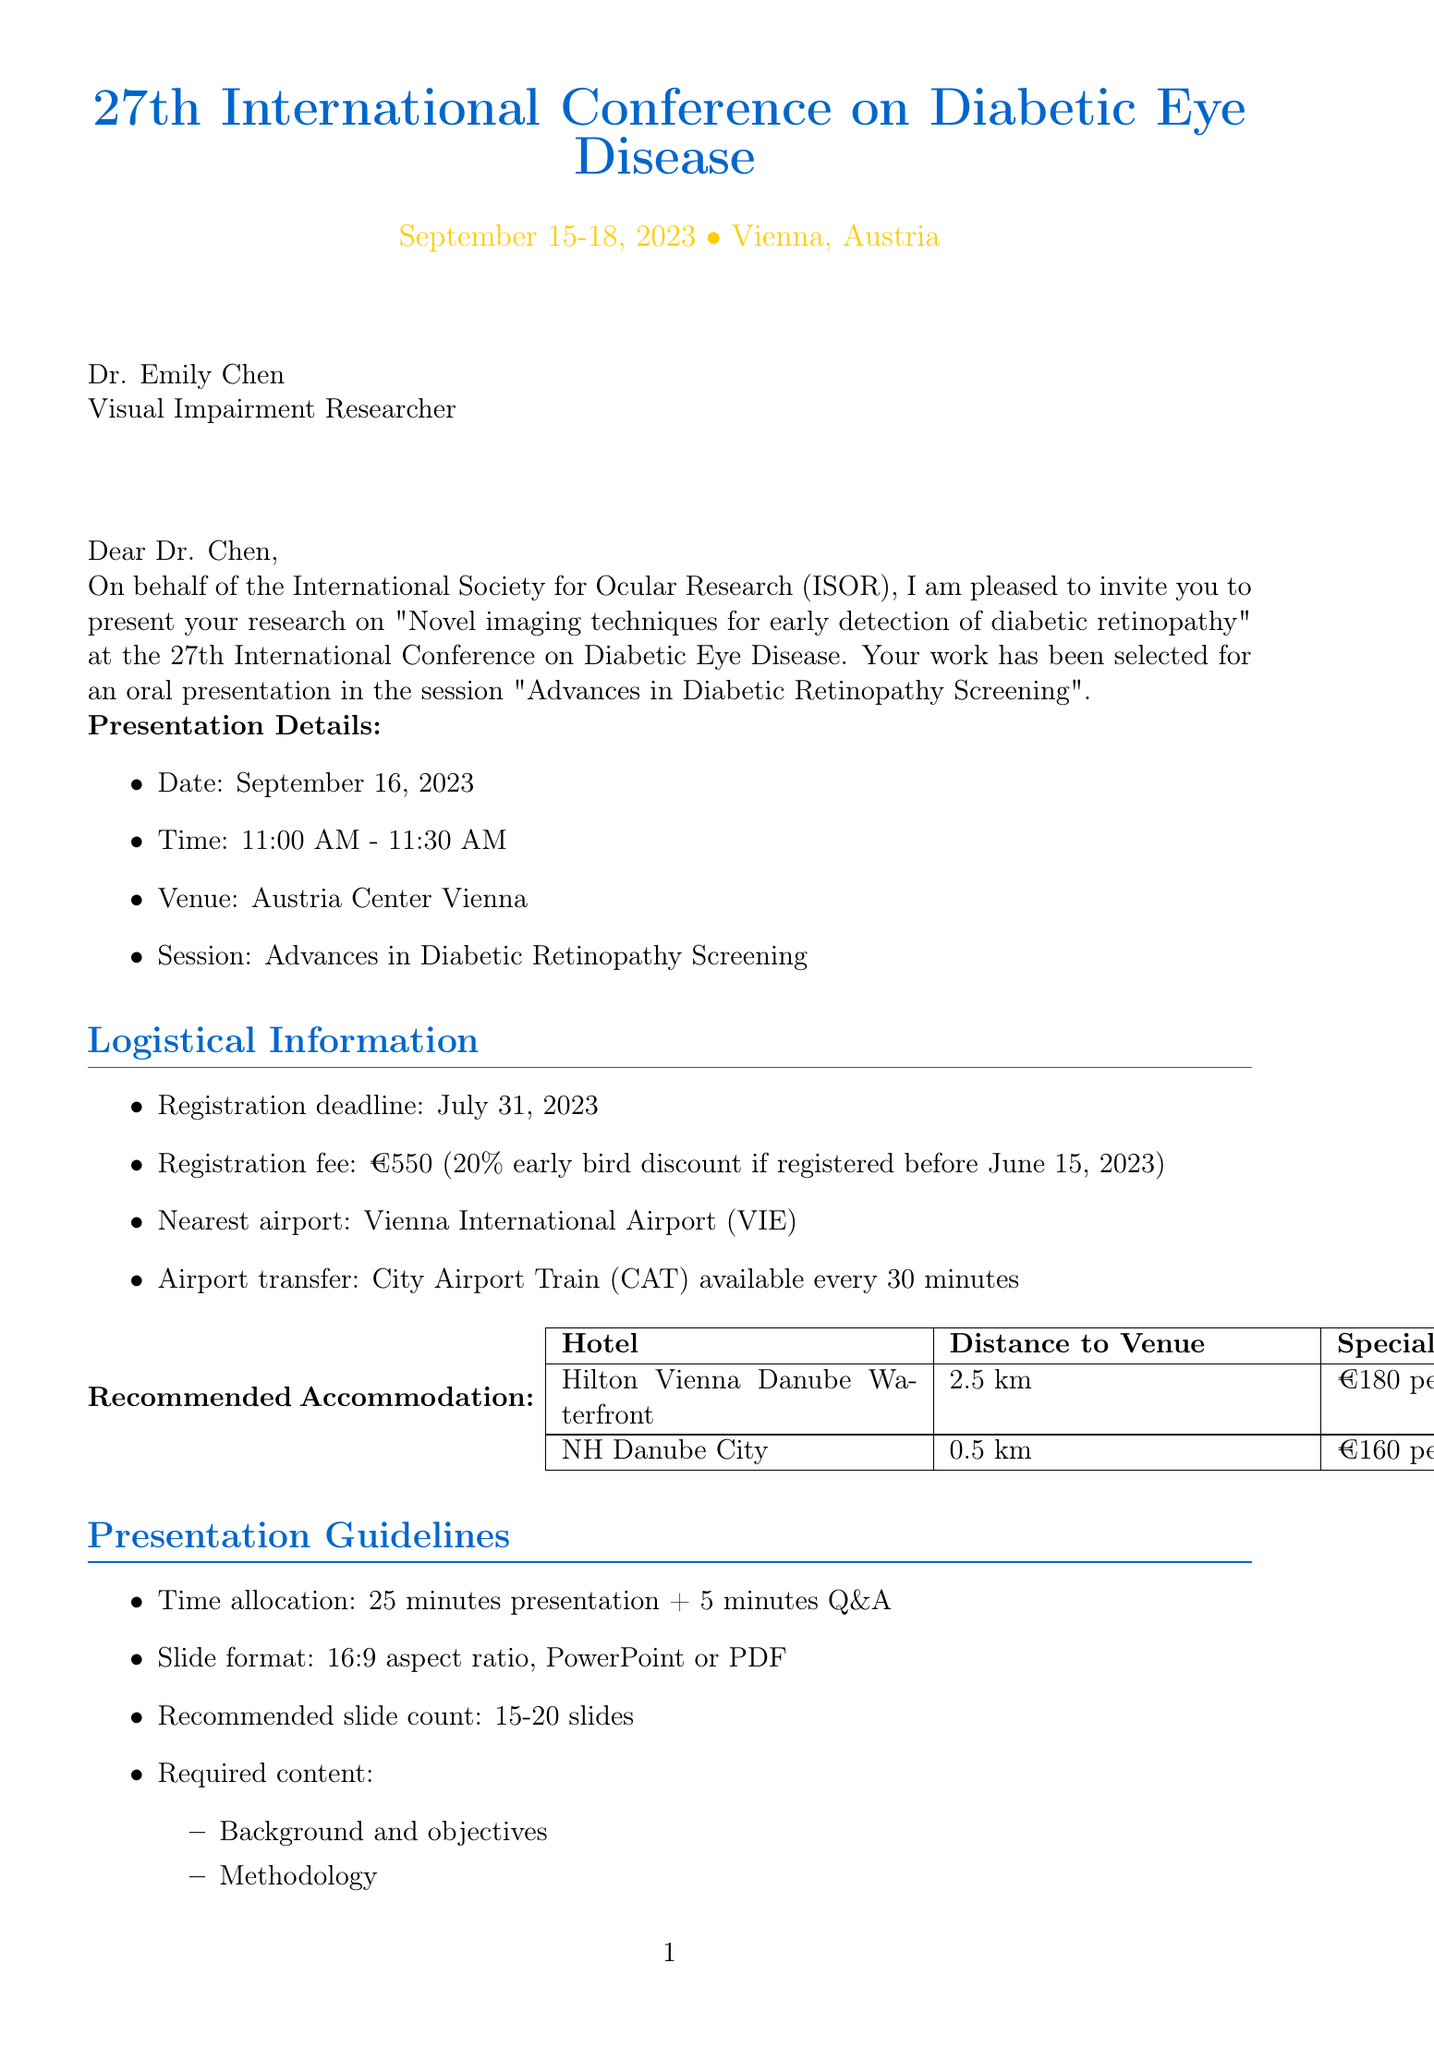What is the date of the conference? The date of the conference is explicitly mentioned in the document as September 15-18, 2023.
Answer: September 15-18, 2023 Who is the sender of the invitation? The sender of the invitation is identified in the document as Dr. Markus Schmidt, who is the Conference Chair.
Answer: Dr. Markus Schmidt What is the registration deadline? The registration deadline is specified in the logistical details as July 31, 2023.
Answer: July 31, 2023 How long is the allocated presentation time? The time allocation for the presentation is outlined in the guidelines as 25 minutes presentation plus 5 minutes for Q&A.
Answer: 25 minutes Which hotel is closest to the venue? The document lists accommodation options and specifies NH Danube City as the hotel that is 0.5 km from the venue, making it the closest option.
Answer: NH Danube City What is the registration fee? The registration fee is mentioned in the logistical information section as €550.
Answer: €550 When is the submission deadline for the presentation? The submission deadline for the presentation is highlighted as September 1, 2023.
Answer: September 1, 2023 What is provided to assist with visa applications? The document states that an invitation letter is provided upon request for visa application purposes.
Answer: Invitation letter What type of presentation has Dr. Chen been invited to give? The invitation specifies that Dr. Chen has been invited to give an oral presentation.
Answer: Oral presentation 